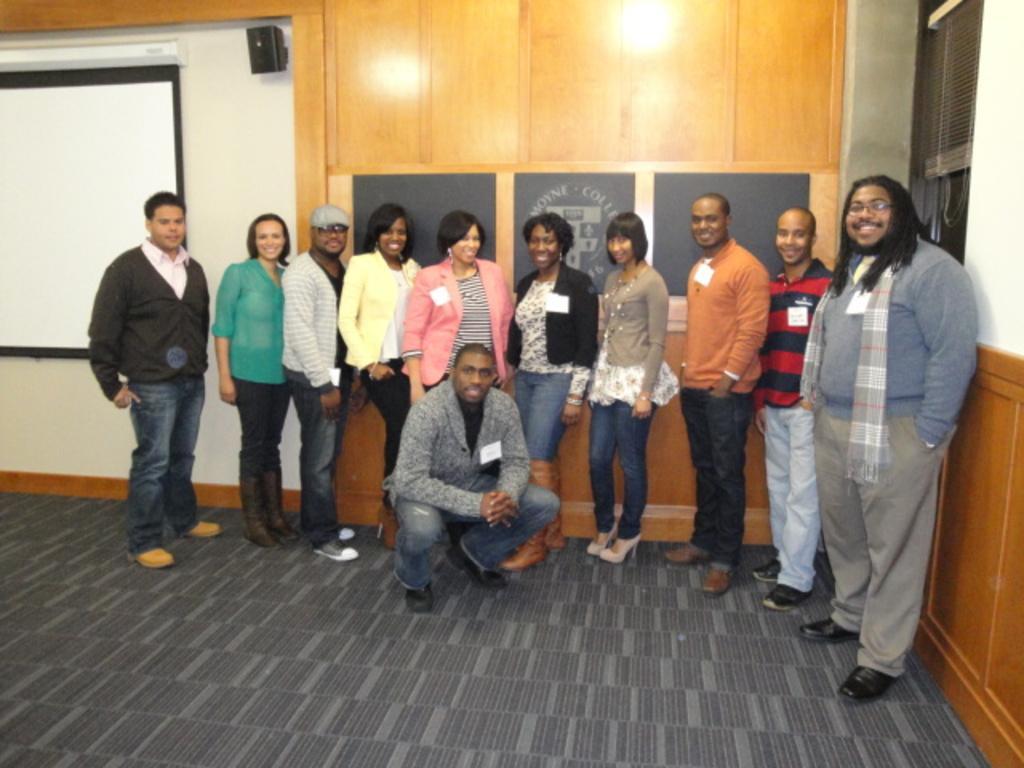Could you give a brief overview of what you see in this image? In this image we can see a group of people on the floor. We can also see a display screen, a speaker box, some boards on a wall and a window blind. 